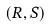Convert formula to latex. <formula><loc_0><loc_0><loc_500><loc_500>( R , S )</formula> 